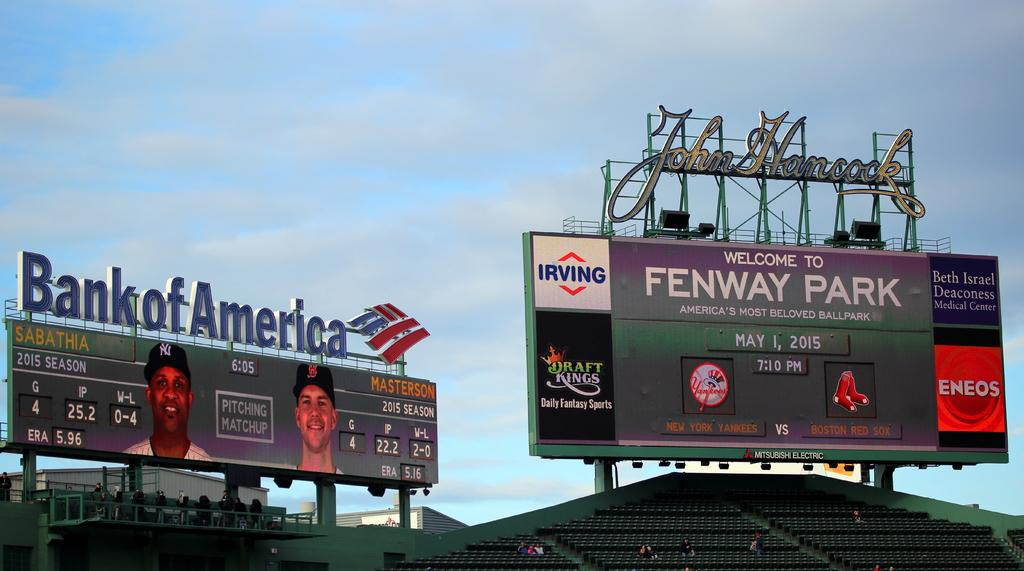<image>
Describe the image concisely. Scoreboard for Fenway Park showing advertisement for Irving. 